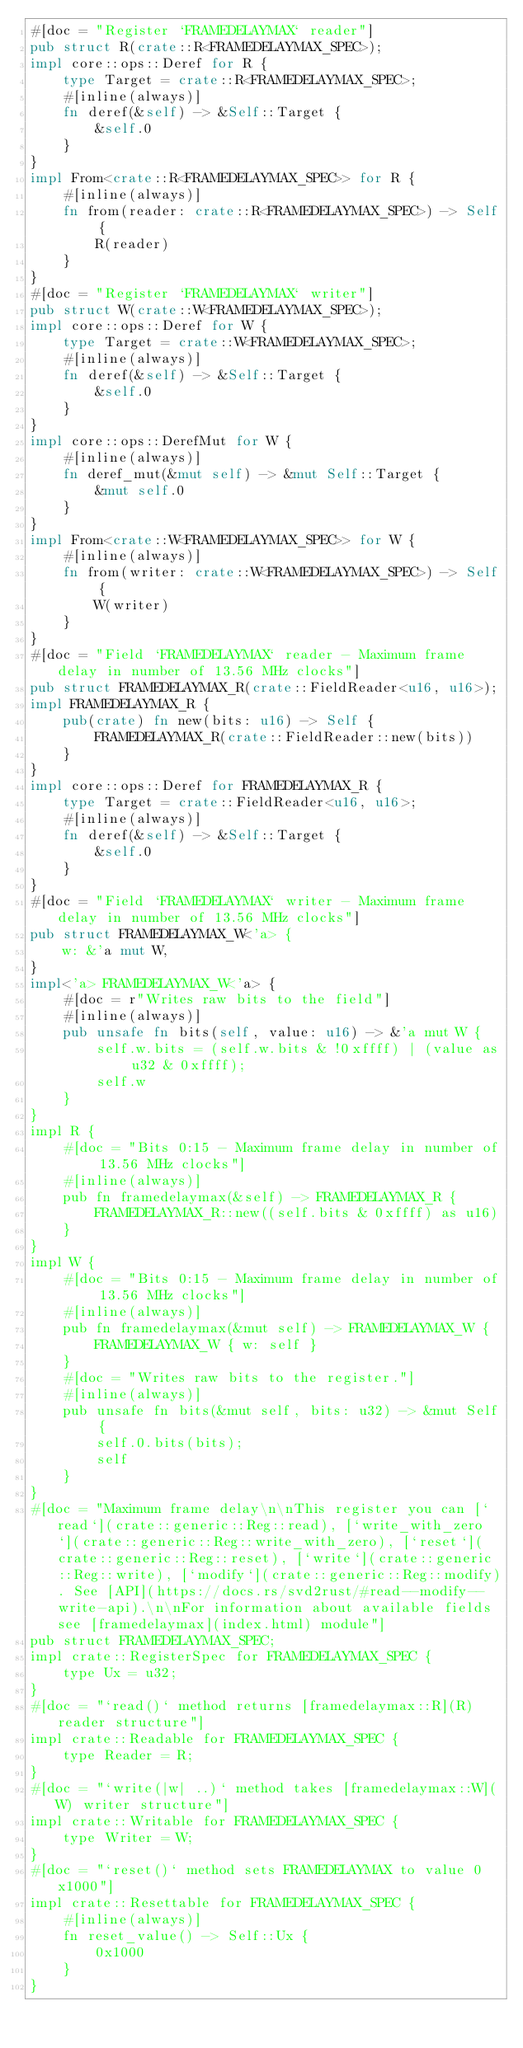<code> <loc_0><loc_0><loc_500><loc_500><_Rust_>#[doc = "Register `FRAMEDELAYMAX` reader"]
pub struct R(crate::R<FRAMEDELAYMAX_SPEC>);
impl core::ops::Deref for R {
    type Target = crate::R<FRAMEDELAYMAX_SPEC>;
    #[inline(always)]
    fn deref(&self) -> &Self::Target {
        &self.0
    }
}
impl From<crate::R<FRAMEDELAYMAX_SPEC>> for R {
    #[inline(always)]
    fn from(reader: crate::R<FRAMEDELAYMAX_SPEC>) -> Self {
        R(reader)
    }
}
#[doc = "Register `FRAMEDELAYMAX` writer"]
pub struct W(crate::W<FRAMEDELAYMAX_SPEC>);
impl core::ops::Deref for W {
    type Target = crate::W<FRAMEDELAYMAX_SPEC>;
    #[inline(always)]
    fn deref(&self) -> &Self::Target {
        &self.0
    }
}
impl core::ops::DerefMut for W {
    #[inline(always)]
    fn deref_mut(&mut self) -> &mut Self::Target {
        &mut self.0
    }
}
impl From<crate::W<FRAMEDELAYMAX_SPEC>> for W {
    #[inline(always)]
    fn from(writer: crate::W<FRAMEDELAYMAX_SPEC>) -> Self {
        W(writer)
    }
}
#[doc = "Field `FRAMEDELAYMAX` reader - Maximum frame delay in number of 13.56 MHz clocks"]
pub struct FRAMEDELAYMAX_R(crate::FieldReader<u16, u16>);
impl FRAMEDELAYMAX_R {
    pub(crate) fn new(bits: u16) -> Self {
        FRAMEDELAYMAX_R(crate::FieldReader::new(bits))
    }
}
impl core::ops::Deref for FRAMEDELAYMAX_R {
    type Target = crate::FieldReader<u16, u16>;
    #[inline(always)]
    fn deref(&self) -> &Self::Target {
        &self.0
    }
}
#[doc = "Field `FRAMEDELAYMAX` writer - Maximum frame delay in number of 13.56 MHz clocks"]
pub struct FRAMEDELAYMAX_W<'a> {
    w: &'a mut W,
}
impl<'a> FRAMEDELAYMAX_W<'a> {
    #[doc = r"Writes raw bits to the field"]
    #[inline(always)]
    pub unsafe fn bits(self, value: u16) -> &'a mut W {
        self.w.bits = (self.w.bits & !0xffff) | (value as u32 & 0xffff);
        self.w
    }
}
impl R {
    #[doc = "Bits 0:15 - Maximum frame delay in number of 13.56 MHz clocks"]
    #[inline(always)]
    pub fn framedelaymax(&self) -> FRAMEDELAYMAX_R {
        FRAMEDELAYMAX_R::new((self.bits & 0xffff) as u16)
    }
}
impl W {
    #[doc = "Bits 0:15 - Maximum frame delay in number of 13.56 MHz clocks"]
    #[inline(always)]
    pub fn framedelaymax(&mut self) -> FRAMEDELAYMAX_W {
        FRAMEDELAYMAX_W { w: self }
    }
    #[doc = "Writes raw bits to the register."]
    #[inline(always)]
    pub unsafe fn bits(&mut self, bits: u32) -> &mut Self {
        self.0.bits(bits);
        self
    }
}
#[doc = "Maximum frame delay\n\nThis register you can [`read`](crate::generic::Reg::read), [`write_with_zero`](crate::generic::Reg::write_with_zero), [`reset`](crate::generic::Reg::reset), [`write`](crate::generic::Reg::write), [`modify`](crate::generic::Reg::modify). See [API](https://docs.rs/svd2rust/#read--modify--write-api).\n\nFor information about available fields see [framedelaymax](index.html) module"]
pub struct FRAMEDELAYMAX_SPEC;
impl crate::RegisterSpec for FRAMEDELAYMAX_SPEC {
    type Ux = u32;
}
#[doc = "`read()` method returns [framedelaymax::R](R) reader structure"]
impl crate::Readable for FRAMEDELAYMAX_SPEC {
    type Reader = R;
}
#[doc = "`write(|w| ..)` method takes [framedelaymax::W](W) writer structure"]
impl crate::Writable for FRAMEDELAYMAX_SPEC {
    type Writer = W;
}
#[doc = "`reset()` method sets FRAMEDELAYMAX to value 0x1000"]
impl crate::Resettable for FRAMEDELAYMAX_SPEC {
    #[inline(always)]
    fn reset_value() -> Self::Ux {
        0x1000
    }
}
</code> 